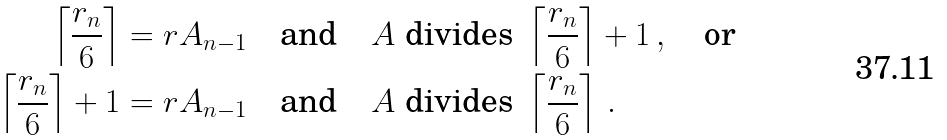<formula> <loc_0><loc_0><loc_500><loc_500>\left \lceil \frac { r _ { n } } 6 \right \rceil = r A _ { n - 1 } \quad & \text {and} \quad A \text {   divides } \left \lceil \frac { r _ { n } } 6 \right \rceil + 1 \, , \quad \text {or} \\ \left \lceil \frac { r _ { n } } 6 \right \rceil + 1 = r A _ { n - 1 } \quad & \text {and} \quad A \text {   divides } \left \lceil \frac { r _ { n } } 6 \right \rceil \, .</formula> 